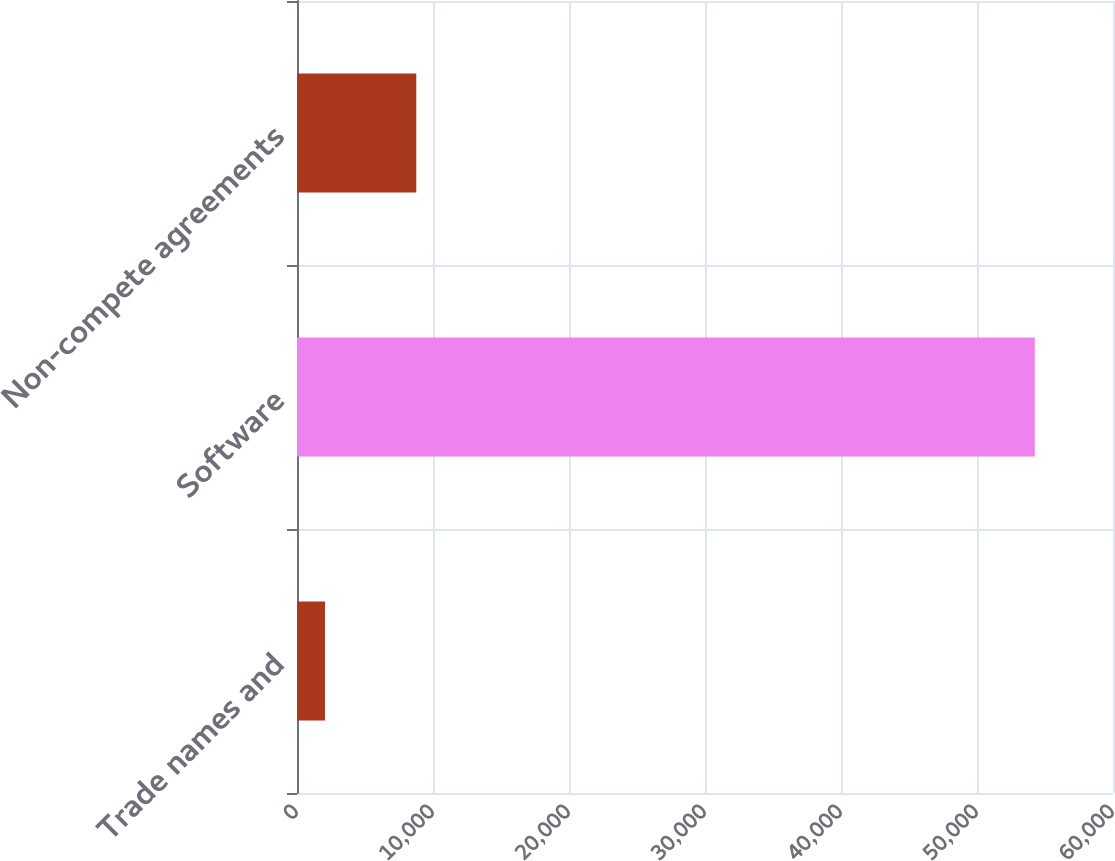Convert chart to OTSL. <chart><loc_0><loc_0><loc_500><loc_500><bar_chart><fcel>Trade names and<fcel>Software<fcel>Non-compete agreements<nl><fcel>2058<fcel>54250<fcel>8770<nl></chart> 